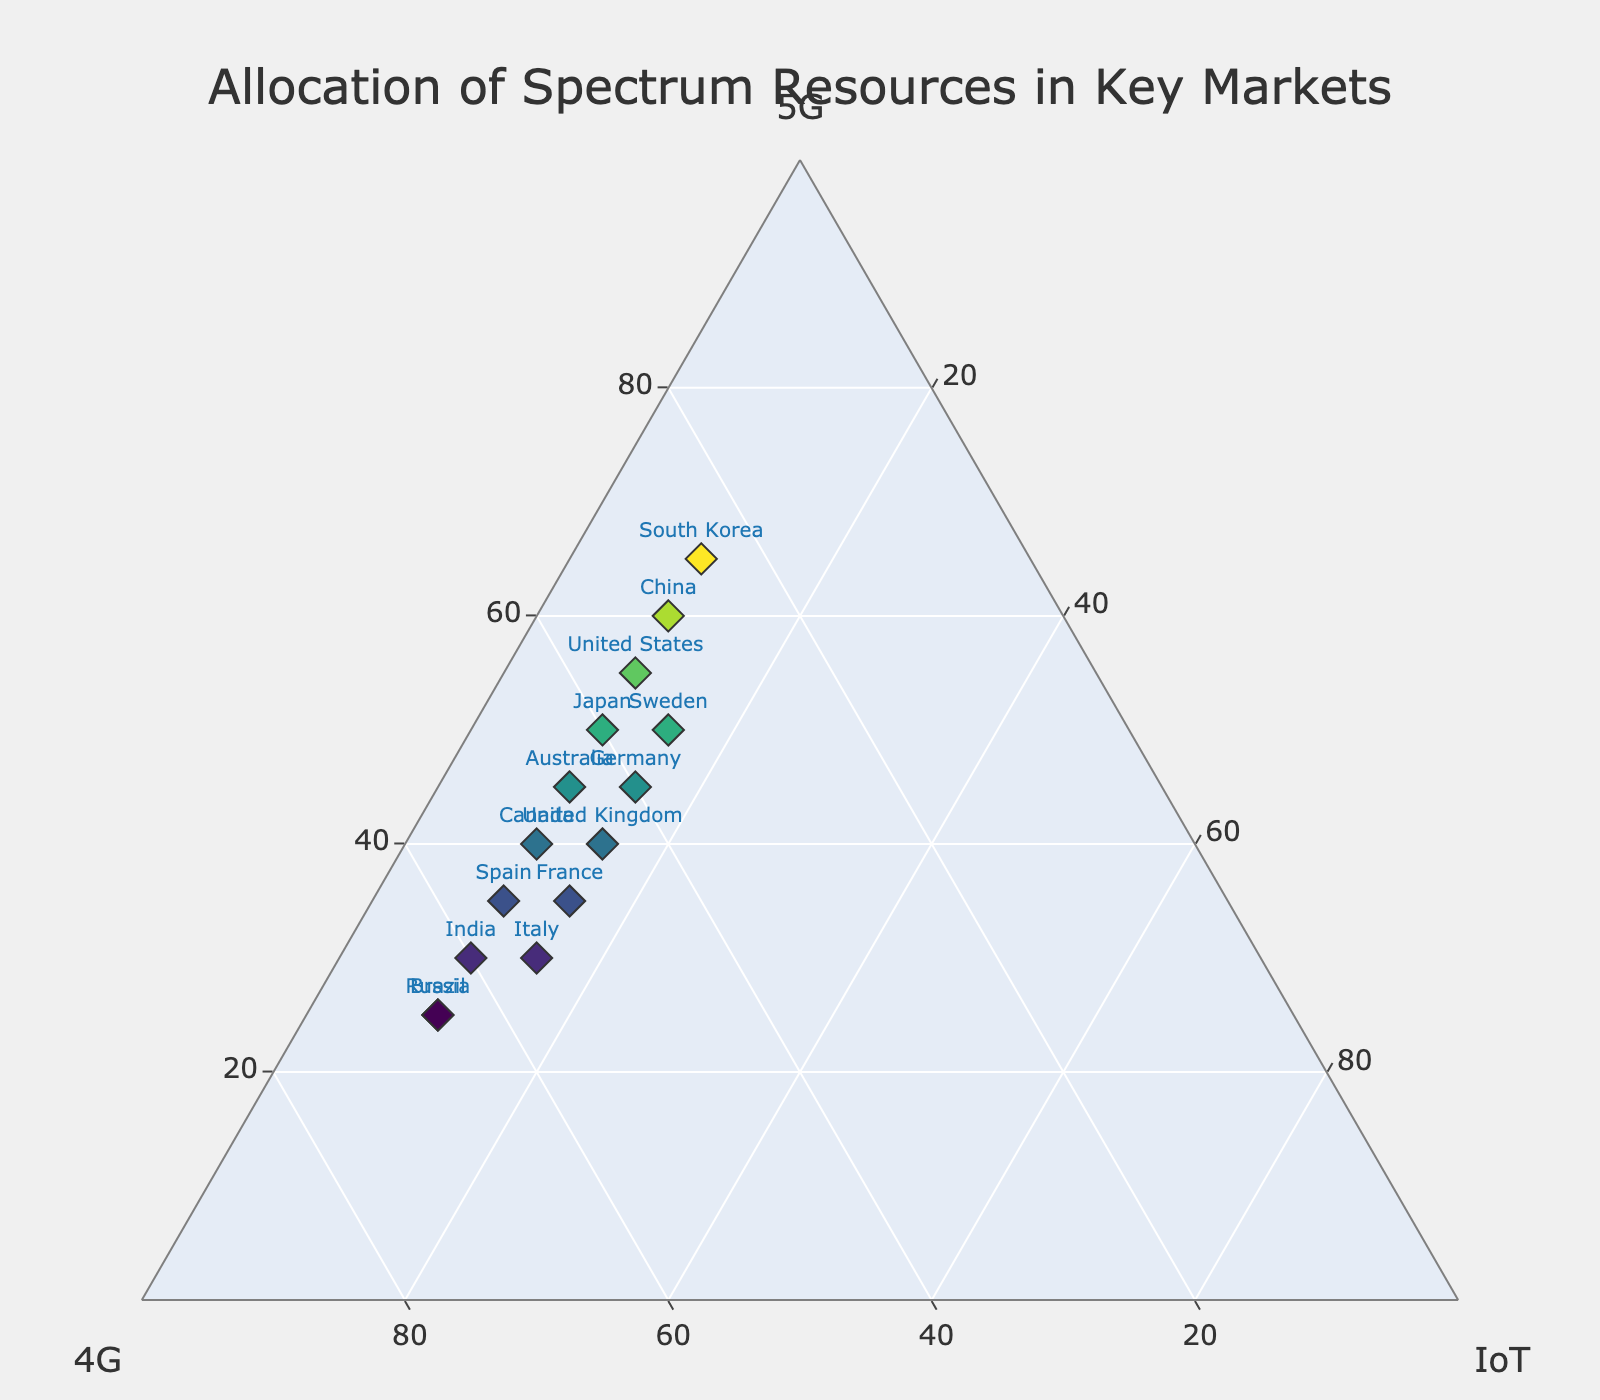What's the title of the figure? The title is usually displayed at the top of the figure. By looking at the top center of the ternary plot, you can identify the title.
Answer: Allocation of Spectrum Resources in Key Markets How many countries allocate more than 50% of their spectrum resources to 5G? By examining each data point on the ternary plot, identify the countries where the 5G axis value is greater than 50%. These countries typically appear closer to the vertex labeled '5G'.
Answer: 5 Which country allocates the highest percentage of spectrum resources to 4G? Identify the data point furthest towards the vertex labeled '4G'. The country closest to the '4G' vertex has allocated the highest percentage.
Answer: Brazil Compare the allocation of spectrum resources between the United States and China. Which country allocates more to 5G? Locate the points representing the United States and China. Compare their distances along the '5G' axis to see which one has a higher value.
Answer: China How many countries allocate exactly 10% of their resources to IoT? Look for the data points that have their 'IoT' axis value marked as 10%. Count these points to get the total number.
Answer: 12 Which country has a balanced allocation between 5G and 4G? A balanced allocation means that the percentages for 5G and 4G are very close. Identify the point closest to the center line between 5G and 4G along the ternary axes.
Answer: Australia Is there a country that allocates more to IoT compared to the other two technologies? Examine each country's data point to see if any point is closer to the 'IoT' vertex than to the other two vertices.
Answer: No What's the average percentage allocated to IoT across all countries? Sum up the IoT percentages for all countries and divide by the number of countries (15) to get the average.
Answer: 11 Identify the country with the lowest percentage allocation to 4G. Find the data point closest to the opposite side of the '4G' vertex, meaning it has the lowest value along the 4G axis.
Answer: South Korea How does the spectrum resource allocation in India compare to Canada? Locate points for India and Canada. Compare their positions in terms of the percentages allocated to 5G, 4G, and IoT. Identify differences and similarities visually.
Answer: India allocates more to 4G whereas Canada allocates more to 5G 